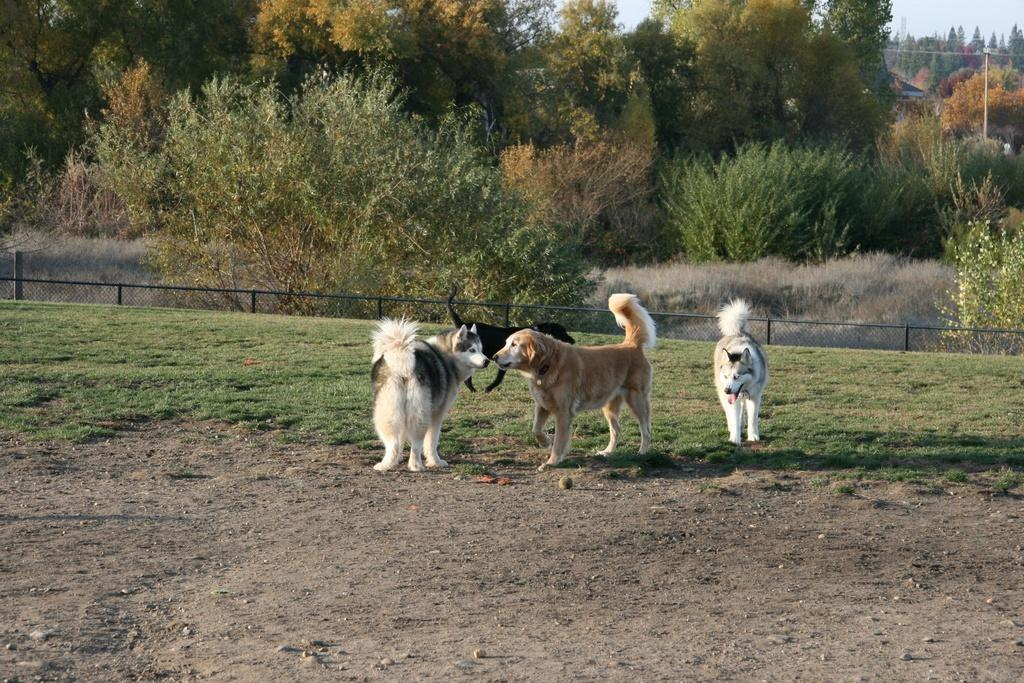What animals can be seen in the image? There are dogs in the image. What type of vegetation is present in the image? There are trees in the image. What type of structure is visible in the image? There is a house in the image. What object can be seen standing upright in the image? There is a pole in the image. What is the condition of the sky in the image? The sky is cloudy in the image. What type of ground surface is visible in the image? There is grass on the ground in the image. What type of notebook is being used by the cabbage in the image? There is no notebook or cabbage present in the image. How does the wind affect the dogs in the image? There is no mention of wind in the image, and therefore its effect on the dogs cannot be determined. 